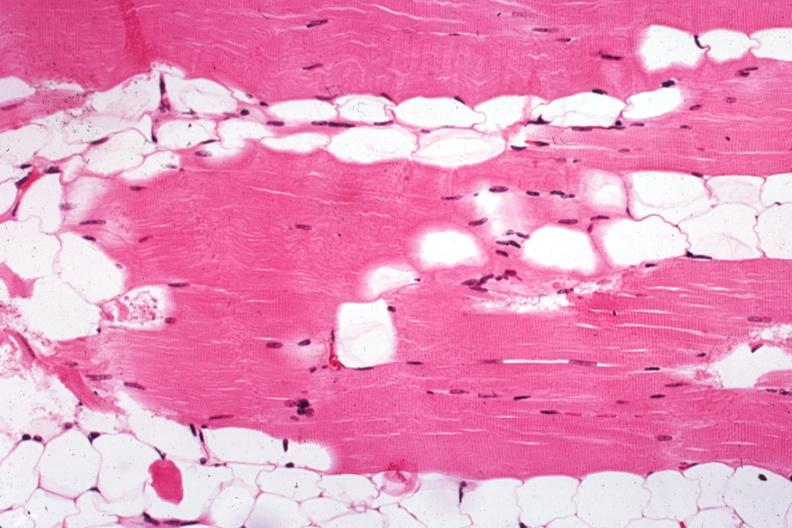does metastatic carcinoma show excellent example case of myasthenia gravis treated?
Answer the question using a single word or phrase. No 